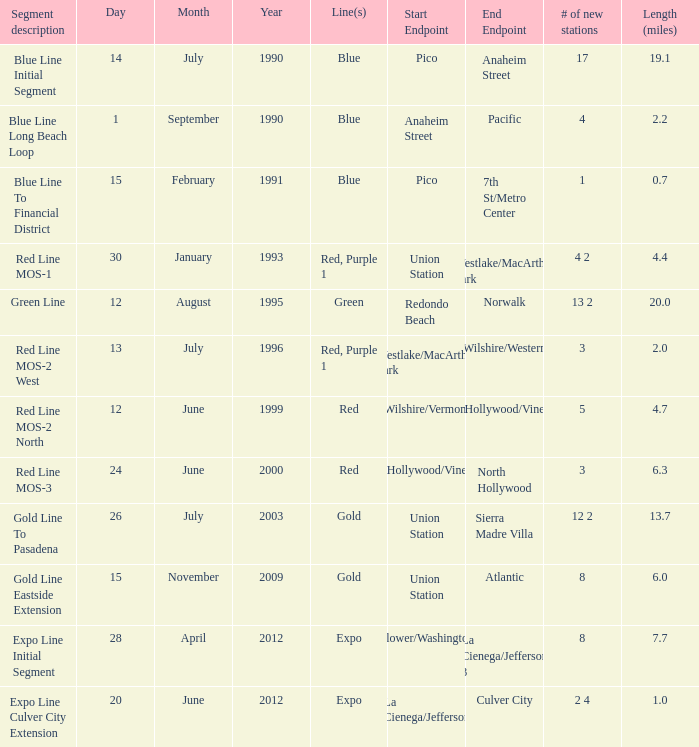What is the lenth (miles) of endpoints westlake/macarthur park to wilshire/western? 2.0. 